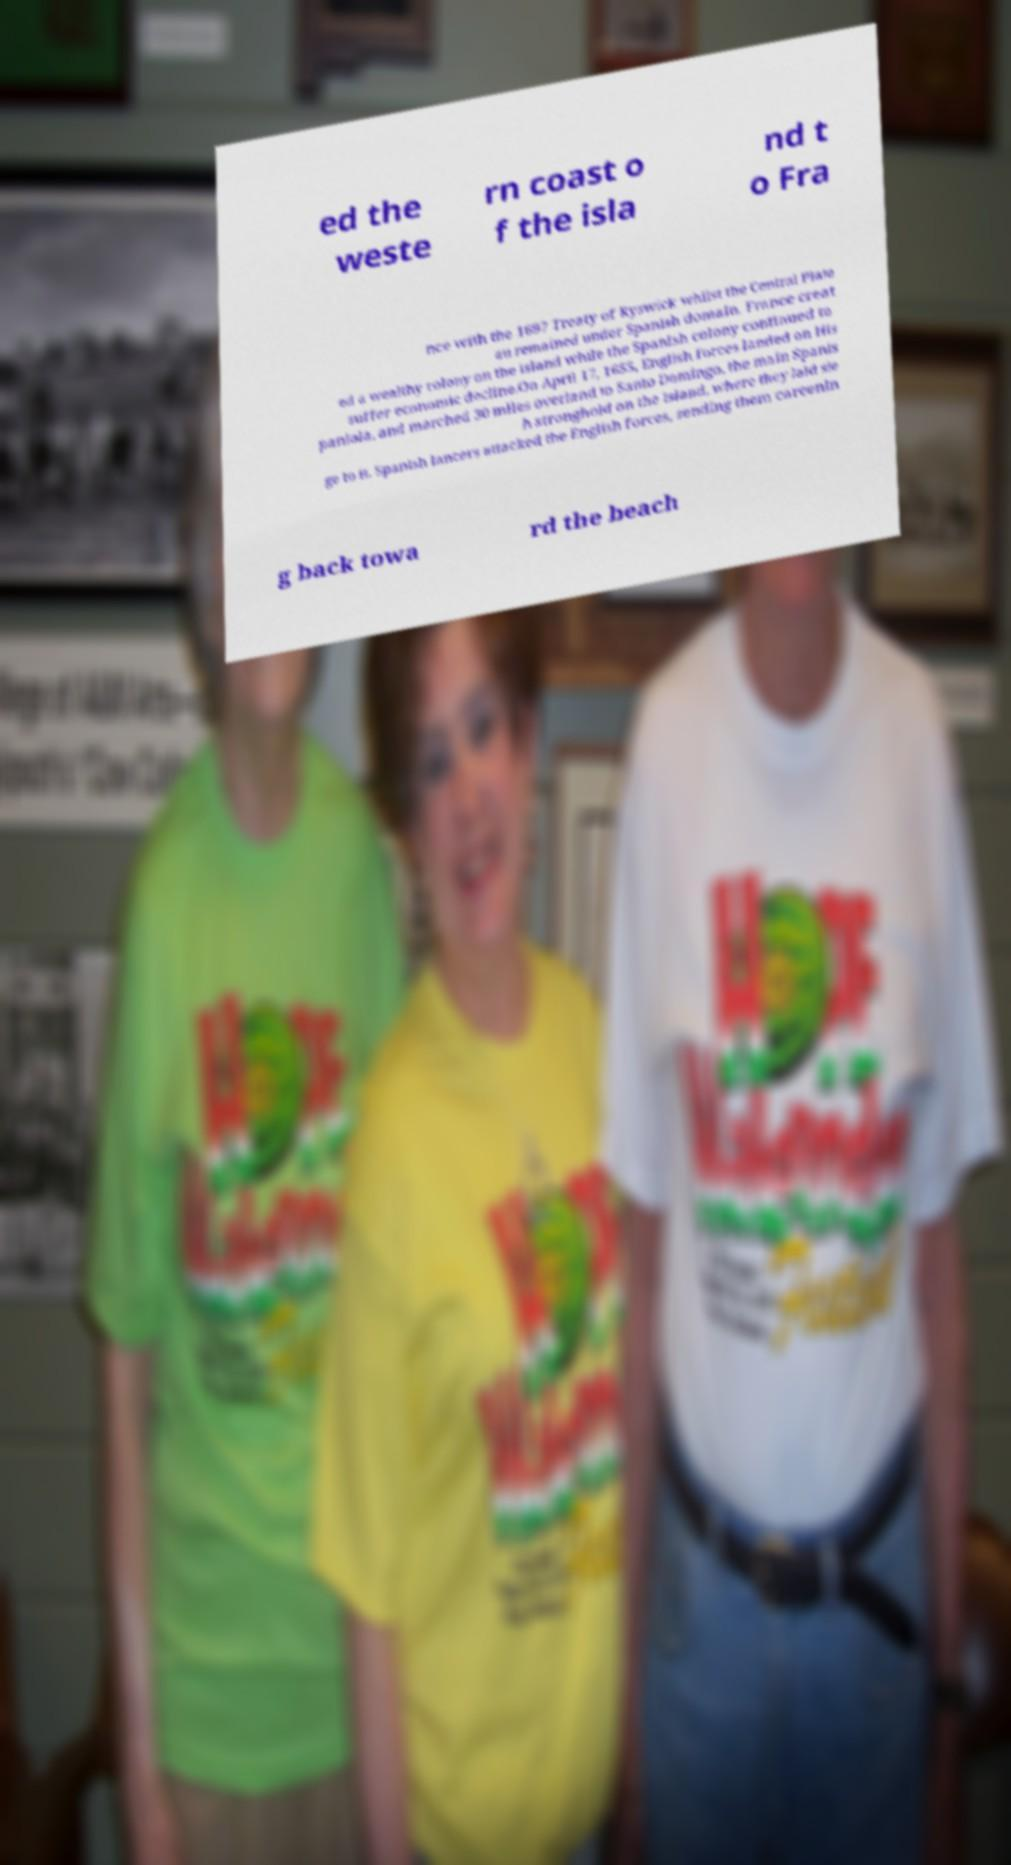Could you extract and type out the text from this image? ed the weste rn coast o f the isla nd t o Fra nce with the 1697 Treaty of Ryswick whilst the Central Plate au remained under Spanish domain. France creat ed a wealthy colony on the island while the Spanish colony continued to suffer economic decline.On April 17, 1655, English forces landed on His paniola, and marched 30 miles overland to Santo Domingo, the main Spanis h stronghold on the island, where they laid sie ge to it. Spanish lancers attacked the English forces, sending them careenin g back towa rd the beach 